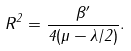<formula> <loc_0><loc_0><loc_500><loc_500>R ^ { 2 } = \frac { \beta ^ { \prime } } { 4 ( \mu - \lambda / 2 ) } .</formula> 